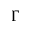<formula> <loc_0><loc_0><loc_500><loc_500>\Gamma</formula> 